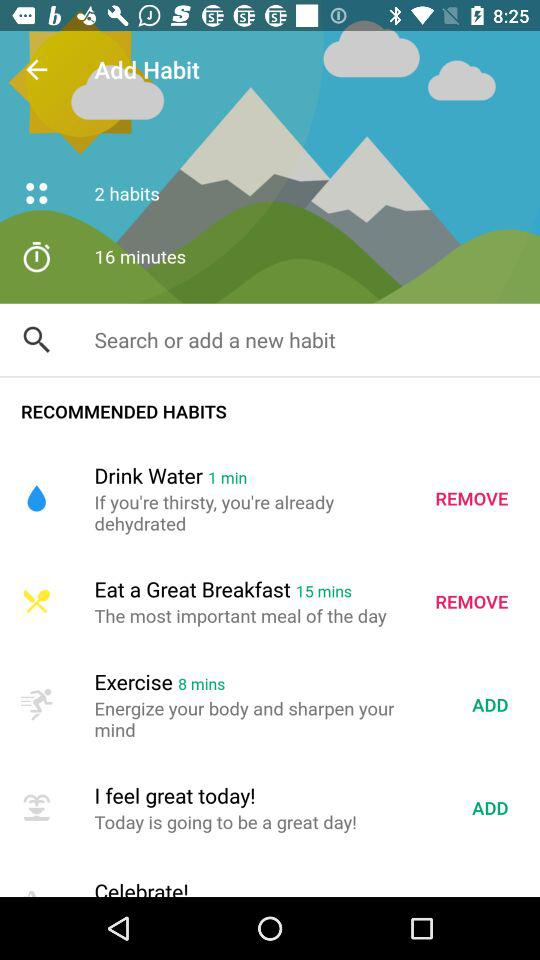Which habits are in the add-on options? The habits are "Exercise" and "I feel great today!". 